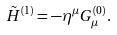<formula> <loc_0><loc_0><loc_500><loc_500>\tilde { H } ^ { ( 1 ) } = - \eta ^ { \mu } G _ { \mu } ^ { ( 0 ) } .</formula> 